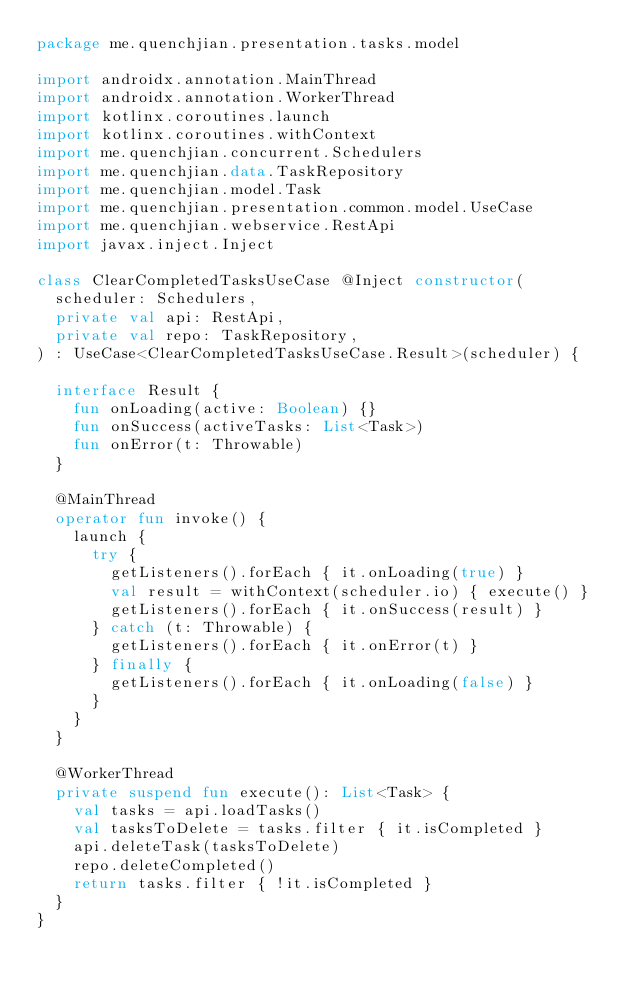<code> <loc_0><loc_0><loc_500><loc_500><_Kotlin_>package me.quenchjian.presentation.tasks.model

import androidx.annotation.MainThread
import androidx.annotation.WorkerThread
import kotlinx.coroutines.launch
import kotlinx.coroutines.withContext
import me.quenchjian.concurrent.Schedulers
import me.quenchjian.data.TaskRepository
import me.quenchjian.model.Task
import me.quenchjian.presentation.common.model.UseCase
import me.quenchjian.webservice.RestApi
import javax.inject.Inject

class ClearCompletedTasksUseCase @Inject constructor(
  scheduler: Schedulers,
  private val api: RestApi,
  private val repo: TaskRepository,
) : UseCase<ClearCompletedTasksUseCase.Result>(scheduler) {

  interface Result {
    fun onLoading(active: Boolean) {}
    fun onSuccess(activeTasks: List<Task>)
    fun onError(t: Throwable)
  }

  @MainThread
  operator fun invoke() {
    launch {
      try {
        getListeners().forEach { it.onLoading(true) }
        val result = withContext(scheduler.io) { execute() }
        getListeners().forEach { it.onSuccess(result) }
      } catch (t: Throwable) {
        getListeners().forEach { it.onError(t) }
      } finally {
        getListeners().forEach { it.onLoading(false) }
      }
    }
  }

  @WorkerThread
  private suspend fun execute(): List<Task> {
    val tasks = api.loadTasks()
    val tasksToDelete = tasks.filter { it.isCompleted }
    api.deleteTask(tasksToDelete)
    repo.deleteCompleted()
    return tasks.filter { !it.isCompleted }
  }
}
</code> 